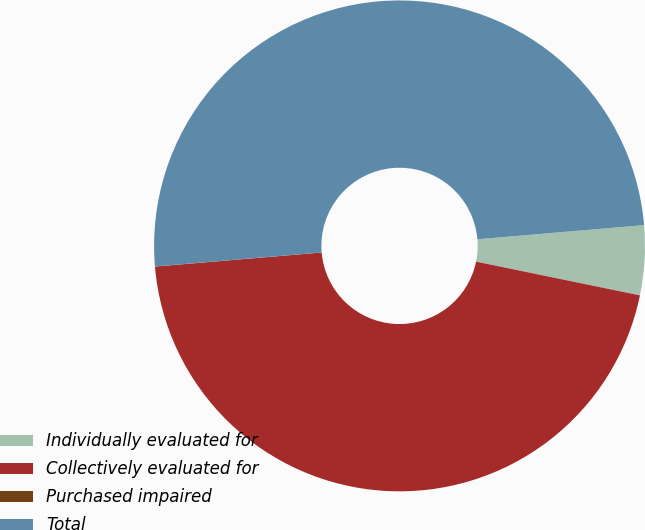Convert chart. <chart><loc_0><loc_0><loc_500><loc_500><pie_chart><fcel>Individually evaluated for<fcel>Collectively evaluated for<fcel>Purchased impaired<fcel>Total<nl><fcel>4.58%<fcel>45.42%<fcel>0.01%<fcel>49.99%<nl></chart> 